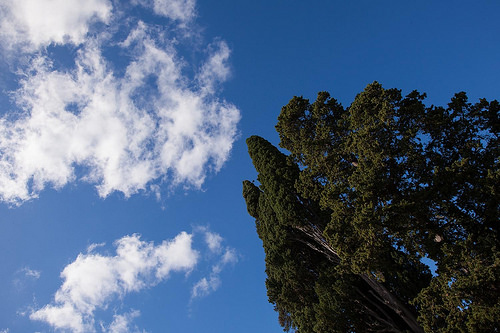<image>
Is there a cloud behind the tree? No. The cloud is not behind the tree. From this viewpoint, the cloud appears to be positioned elsewhere in the scene. 